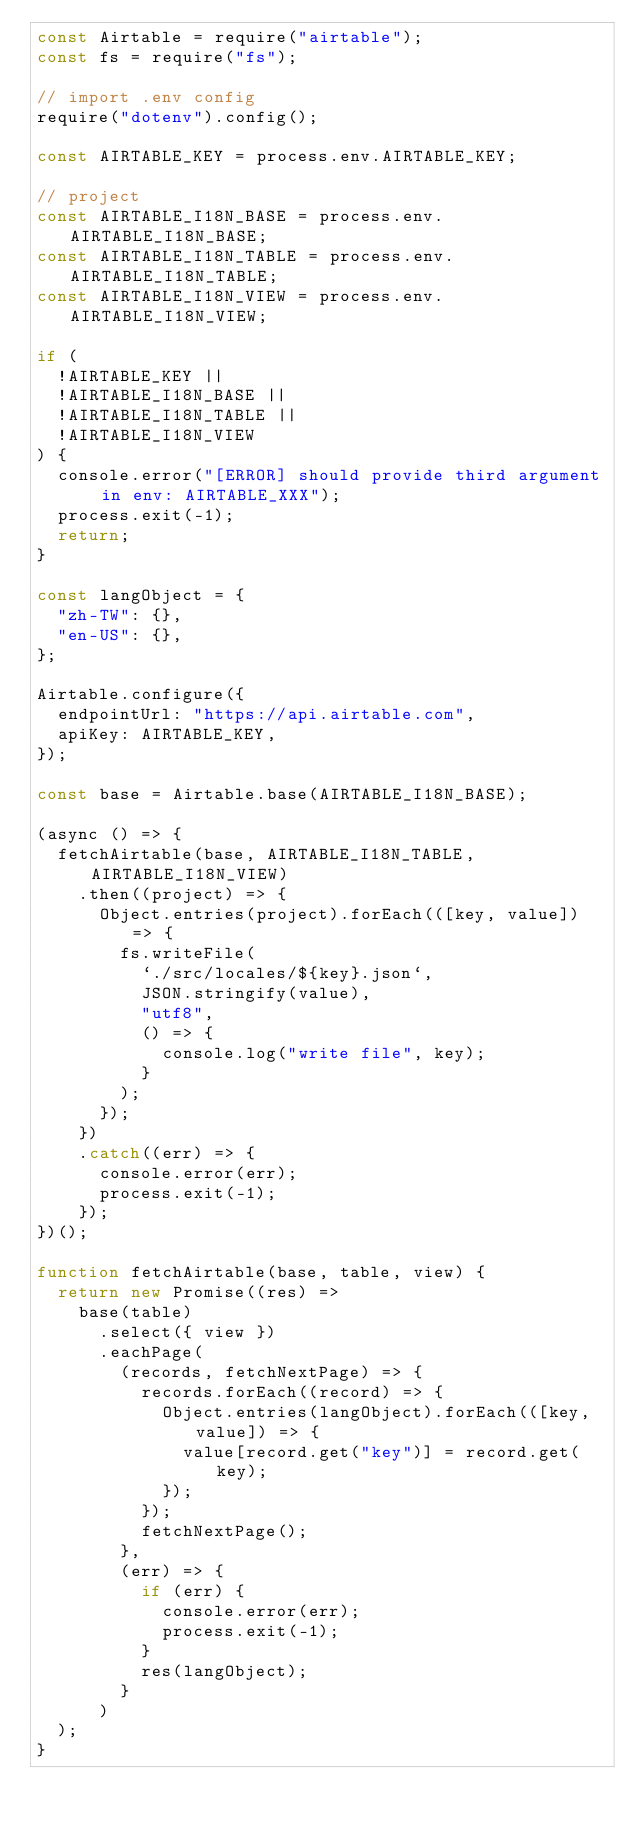Convert code to text. <code><loc_0><loc_0><loc_500><loc_500><_JavaScript_>const Airtable = require("airtable");
const fs = require("fs");

// import .env config
require("dotenv").config();

const AIRTABLE_KEY = process.env.AIRTABLE_KEY;

// project
const AIRTABLE_I18N_BASE = process.env.AIRTABLE_I18N_BASE;
const AIRTABLE_I18N_TABLE = process.env.AIRTABLE_I18N_TABLE;
const AIRTABLE_I18N_VIEW = process.env.AIRTABLE_I18N_VIEW;

if (
  !AIRTABLE_KEY ||
  !AIRTABLE_I18N_BASE ||
  !AIRTABLE_I18N_TABLE ||
  !AIRTABLE_I18N_VIEW
) {
  console.error("[ERROR] should provide third argument in env: AIRTABLE_XXX");
  process.exit(-1);
  return;
}

const langObject = {
  "zh-TW": {},
  "en-US": {},
};

Airtable.configure({
  endpointUrl: "https://api.airtable.com",
  apiKey: AIRTABLE_KEY,
});

const base = Airtable.base(AIRTABLE_I18N_BASE);

(async () => {
  fetchAirtable(base, AIRTABLE_I18N_TABLE, AIRTABLE_I18N_VIEW)
    .then((project) => {
      Object.entries(project).forEach(([key, value]) => {
        fs.writeFile(
          `./src/locales/${key}.json`,
          JSON.stringify(value),
          "utf8",
          () => {
            console.log("write file", key);
          }
        );
      });
    })
    .catch((err) => {
      console.error(err);
      process.exit(-1);
    });
})();

function fetchAirtable(base, table, view) {
  return new Promise((res) =>
    base(table)
      .select({ view })
      .eachPage(
        (records, fetchNextPage) => {
          records.forEach((record) => {
            Object.entries(langObject).forEach(([key, value]) => {
              value[record.get("key")] = record.get(key);
            });
          });
          fetchNextPage();
        },
        (err) => {
          if (err) {
            console.error(err);
            process.exit(-1);
          }
          res(langObject);
        }
      )
  );
}
</code> 